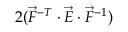<formula> <loc_0><loc_0><loc_500><loc_500>2 ( \vec { F } ^ { - T } \cdot \vec { E } \cdot \vec { F } ^ { - 1 } )</formula> 